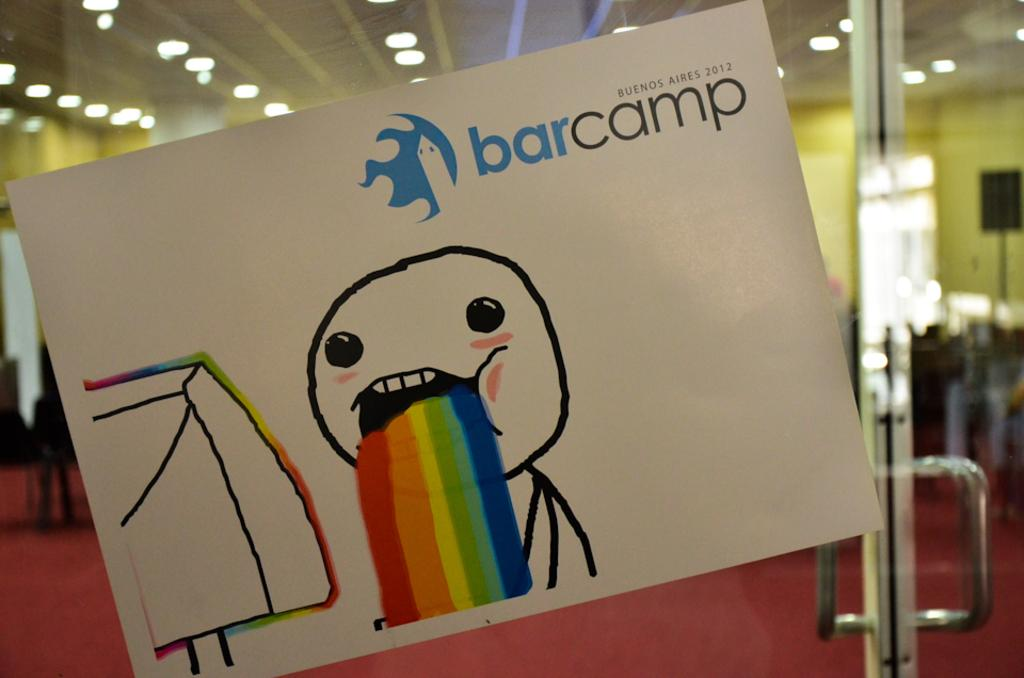Provide a one-sentence caption for the provided image. bar camp in Buenes Aires in the year 2012. 